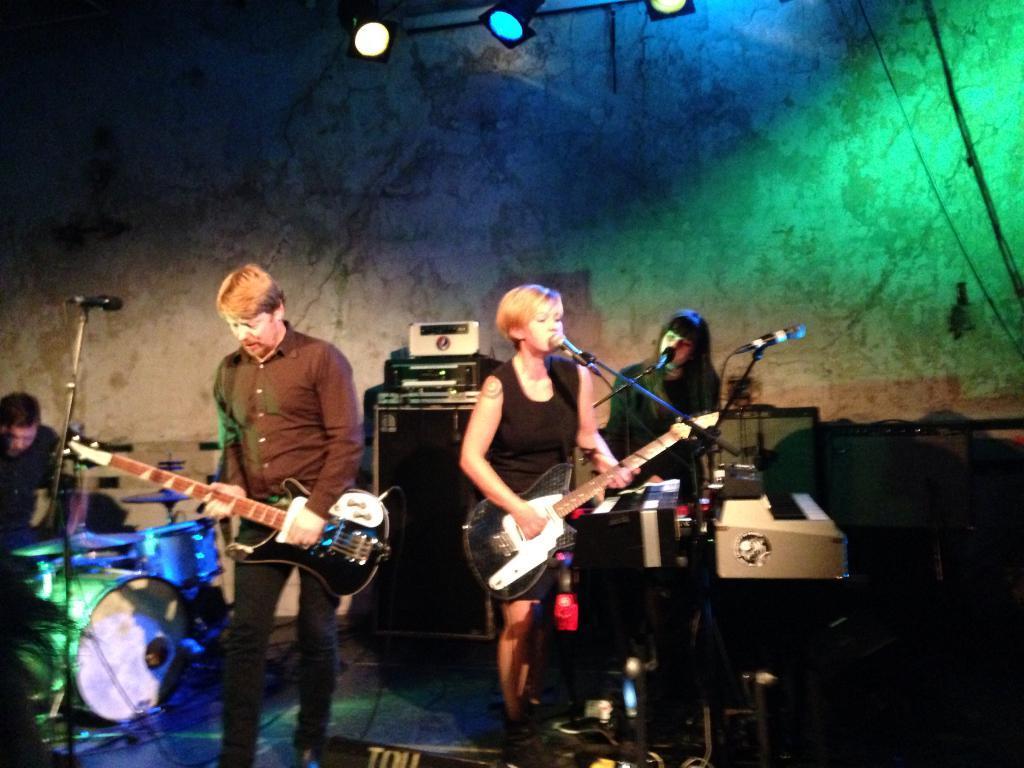How would you summarize this image in a sentence or two? There are few people playing musical instruments and two among them is singing in front of a mic. 